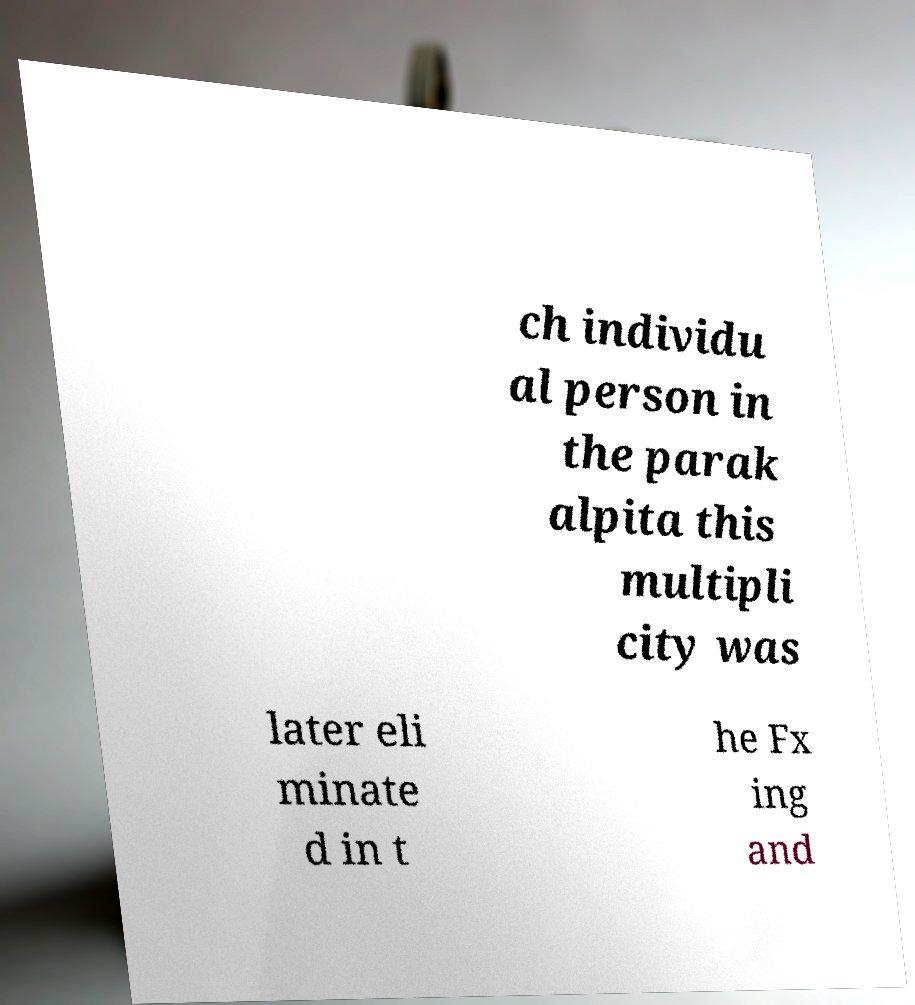Could you assist in decoding the text presented in this image and type it out clearly? ch individu al person in the parak alpita this multipli city was later eli minate d in t he Fx ing and 